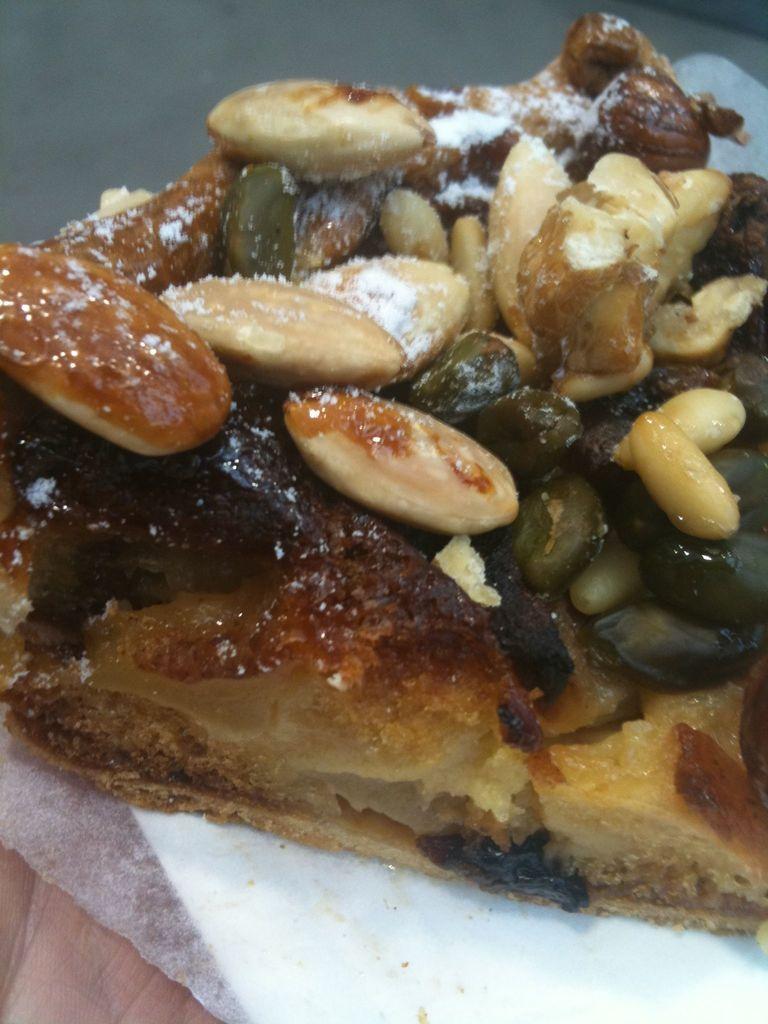Please provide a concise description of this image. In this image we can see a food item. 